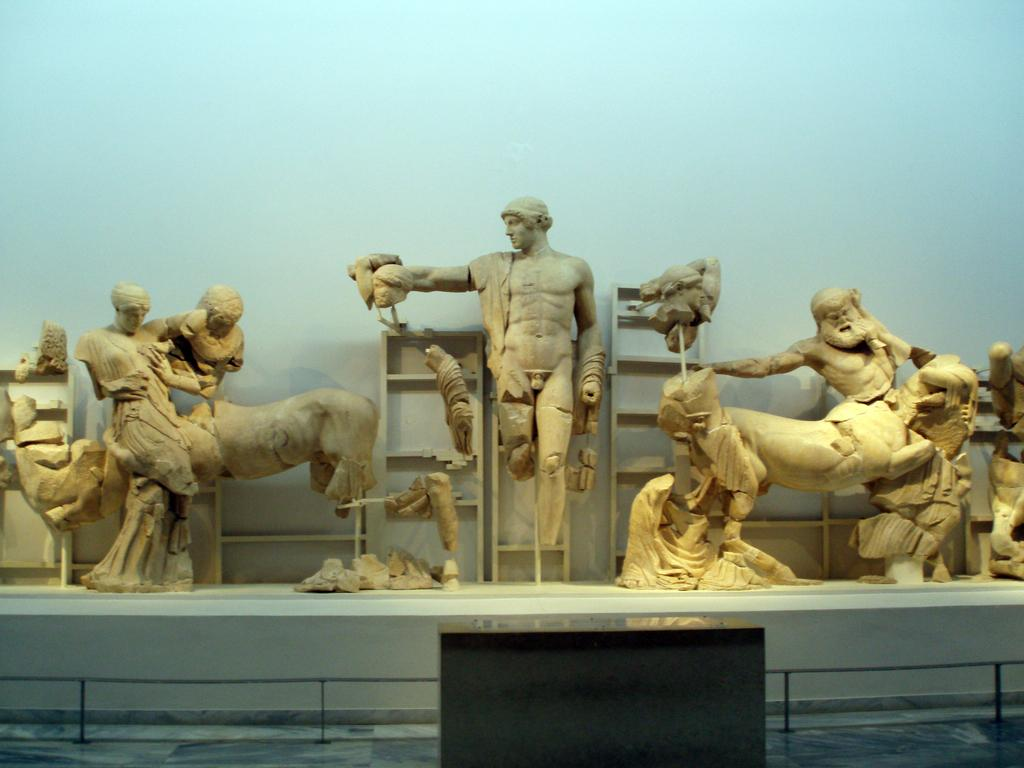What type of objects can be seen in the image? There are statues in the image. What color are the statues? The statues are in cream color. What color is the surface on which the statues are placed? The statues are on a white color surface. What colors can be seen in the background of the image? The background of the image is in blue and white color. What type of lunch is being served on the white surface in the image? There is no lunch or food present in the image; it features statues on a white surface with a blue and white background. What type of support is the statue using to stand upright in the image? The statues are standing on a white surface, and no additional support is visible in the image. 